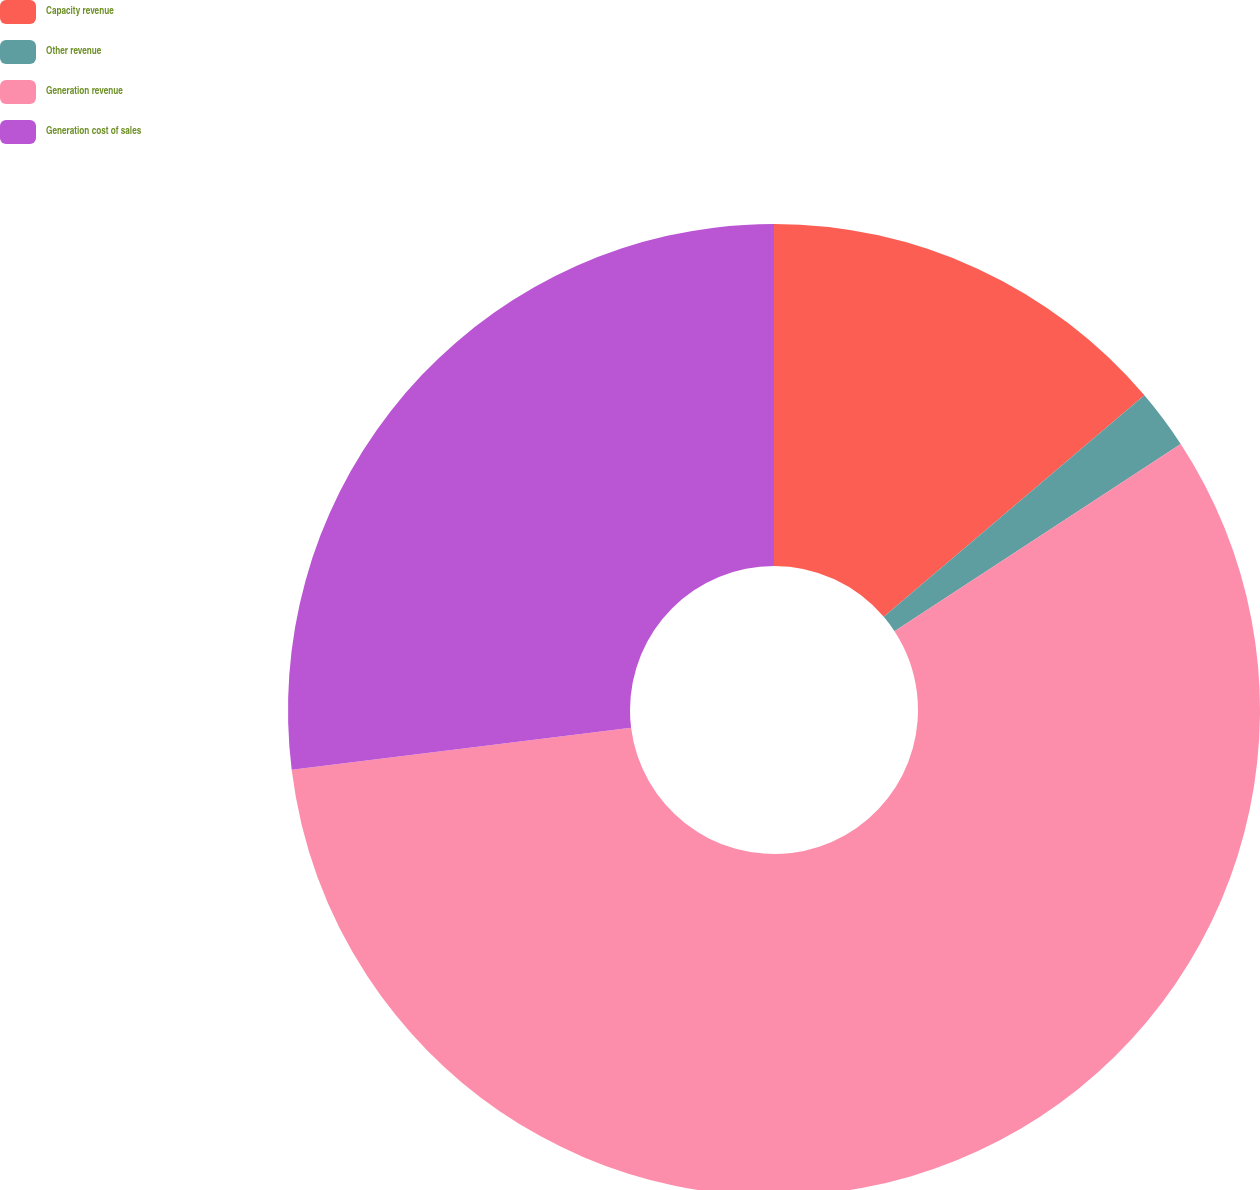Convert chart. <chart><loc_0><loc_0><loc_500><loc_500><pie_chart><fcel>Capacity revenue<fcel>Other revenue<fcel>Generation revenue<fcel>Generation cost of sales<nl><fcel>13.79%<fcel>1.99%<fcel>57.25%<fcel>26.96%<nl></chart> 